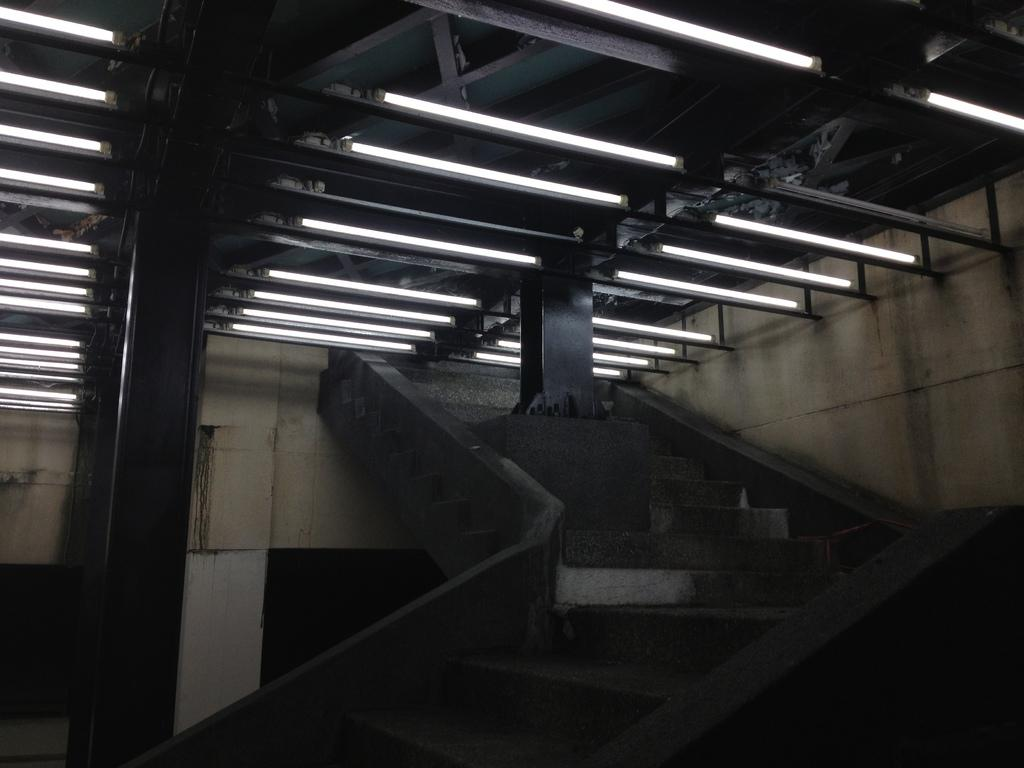What type of architectural feature is present in the image? There are stairs in the image. What else can be seen in the image besides the stairs? There is a wall in the image. Are there any lighting features in the image? Yes, there are lights attached to the roof in the image. How many cats are sitting on the knot in the image? There are no cats or knots present in the image. What type of water-related structure can be seen in the image? There is no water-related structure, such as a harbor, present in the image. 